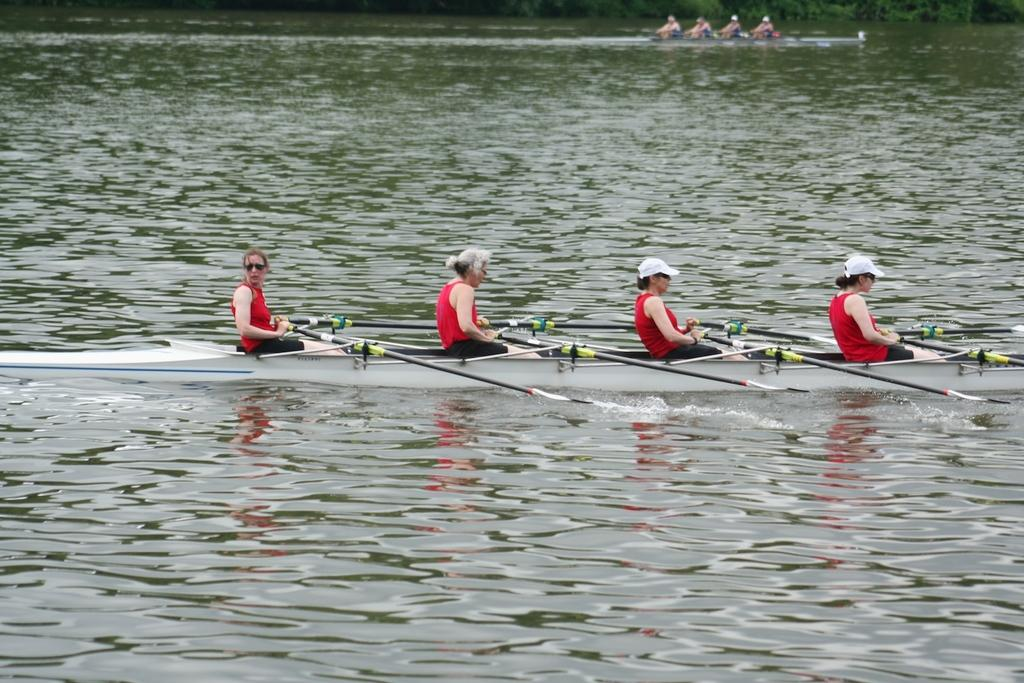Who is present in the image? There are people in the image. What are the people doing in the image? The people are riding boats. Where are the boats located in the image? The boats are in the water. What type of coil is being used by the maid in the image? There is no maid or coil present in the image. 